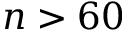<formula> <loc_0><loc_0><loc_500><loc_500>n > 6 0</formula> 